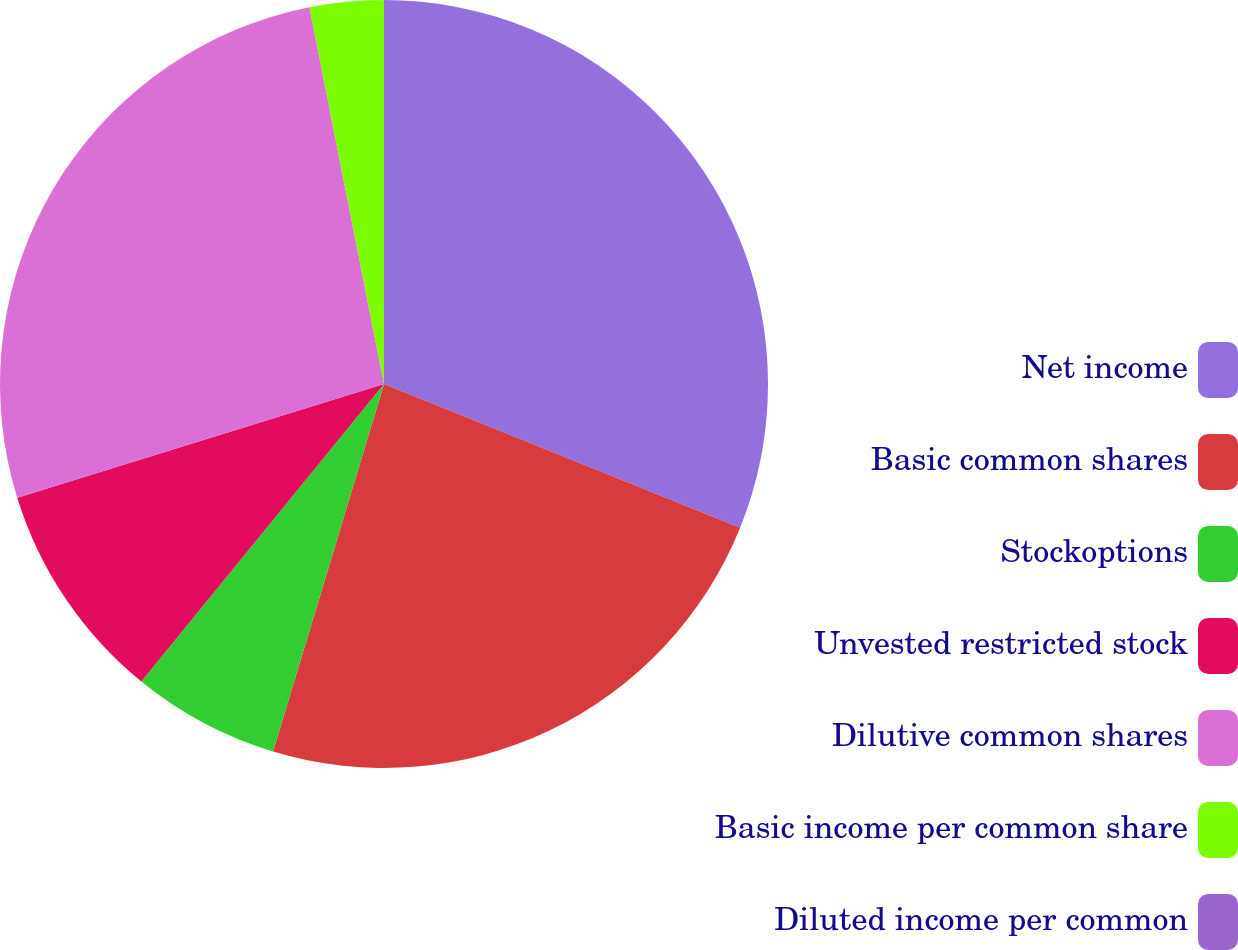Convert chart. <chart><loc_0><loc_0><loc_500><loc_500><pie_chart><fcel>Net income<fcel>Basic common shares<fcel>Stockoptions<fcel>Unvested restricted stock<fcel>Dilutive common shares<fcel>Basic income per common share<fcel>Diluted income per common<nl><fcel>31.1%<fcel>23.56%<fcel>6.22%<fcel>9.33%<fcel>26.67%<fcel>3.11%<fcel>0.0%<nl></chart> 